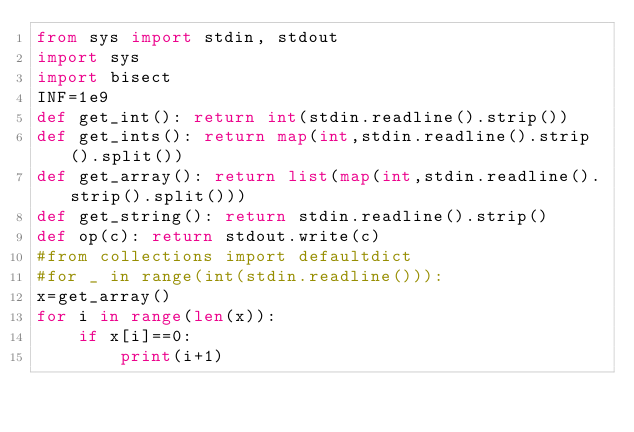<code> <loc_0><loc_0><loc_500><loc_500><_Python_>from sys import stdin, stdout
import sys
import bisect
INF=1e9
def get_int(): return int(stdin.readline().strip())
def get_ints(): return map(int,stdin.readline().strip().split()) 
def get_array(): return list(map(int,stdin.readline().strip().split()))
def get_string(): return stdin.readline().strip()
def op(c): return stdout.write(c)
#from collections import defaultdict 
#for _ in range(int(stdin.readline())):
x=get_array()
for i in range(len(x)):
    if x[i]==0:
        print(i+1)</code> 